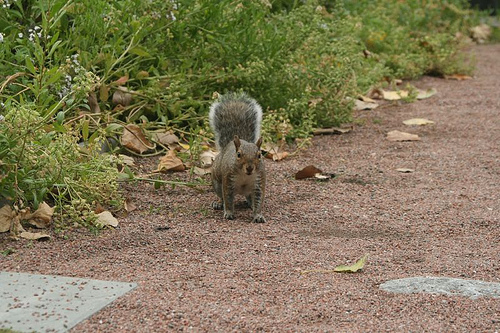<image>
Can you confirm if the grass is behind the squirrel? Yes. From this viewpoint, the grass is positioned behind the squirrel, with the squirrel partially or fully occluding the grass. 